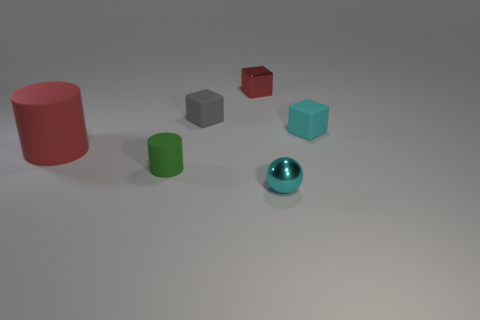Add 4 green things. How many objects exist? 10 Subtract all spheres. How many objects are left? 5 Subtract 1 gray blocks. How many objects are left? 5 Subtract all cyan things. Subtract all cylinders. How many objects are left? 2 Add 6 small gray matte blocks. How many small gray matte blocks are left? 7 Add 6 big cylinders. How many big cylinders exist? 7 